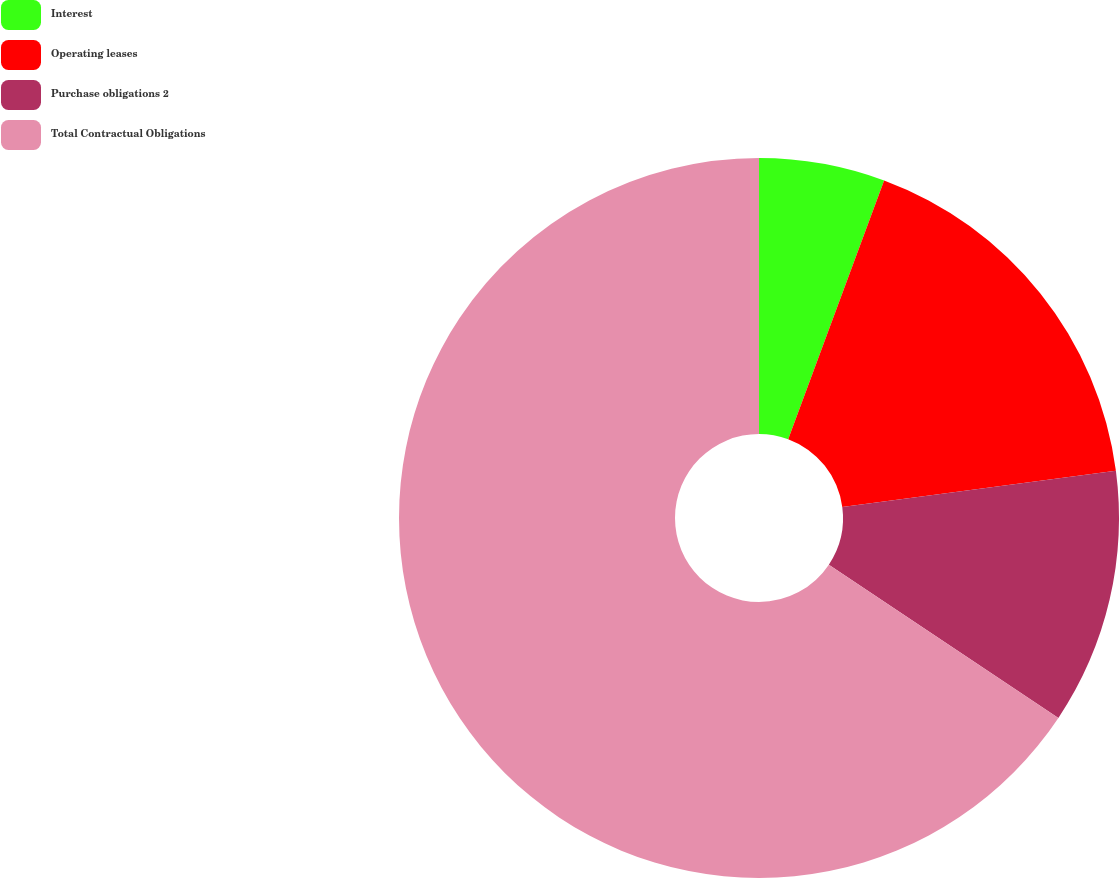Convert chart. <chart><loc_0><loc_0><loc_500><loc_500><pie_chart><fcel>Interest<fcel>Operating leases<fcel>Purchase obligations 2<fcel>Total Contractual Obligations<nl><fcel>5.65%<fcel>17.26%<fcel>11.46%<fcel>65.63%<nl></chart> 